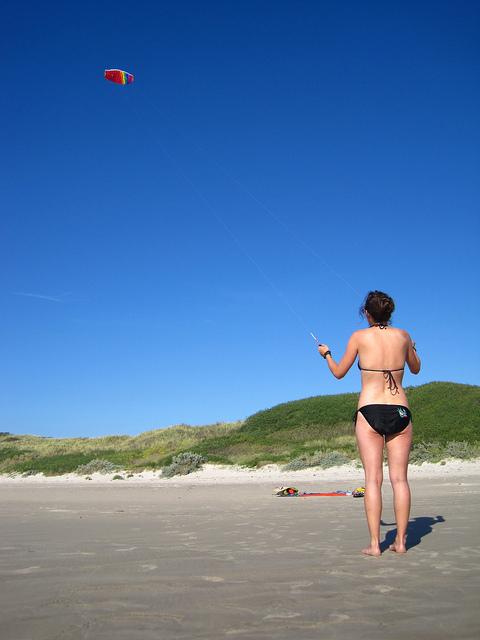What is the weather like?
Be succinct. Sunny. Is this girl water skiing?
Keep it brief. No. What is she controlling?
Quick response, please. Kite. Is this woman wearing a one piece bathing suit?
Concise answer only. No. How many people are in the picture?
Write a very short answer. 1. What in the sky?
Answer briefly. Kite. Is the girl wearing a life vest?
Short answer required. No. 